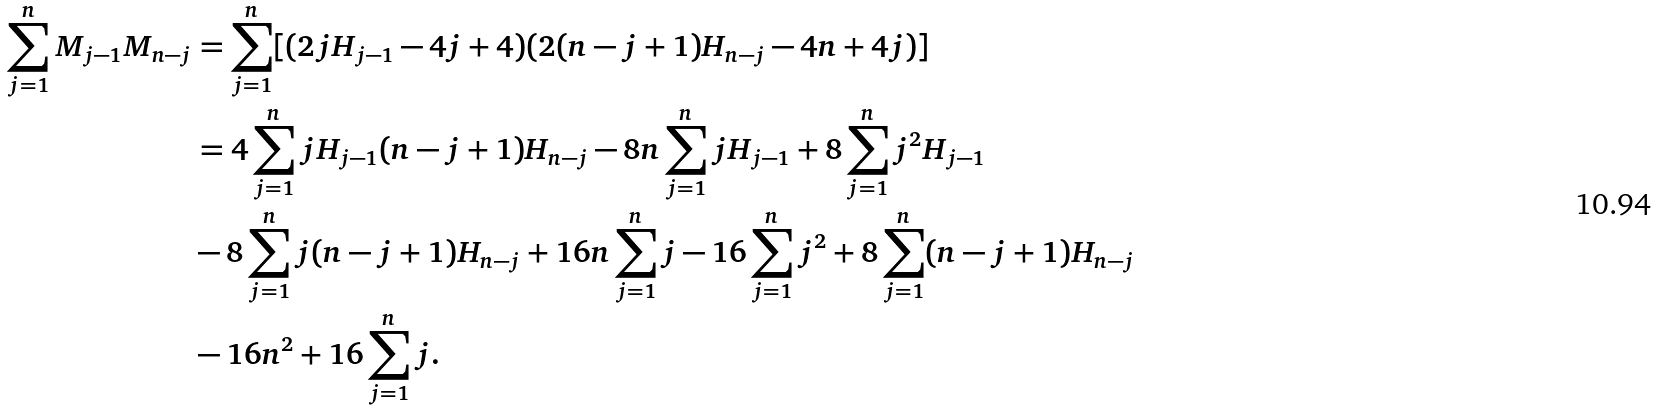<formula> <loc_0><loc_0><loc_500><loc_500>\sum _ { j = 1 } ^ { n } M _ { j - 1 } M _ { n - j } & = \sum _ { j = 1 } ^ { n } [ ( 2 j H _ { j - 1 } - 4 j + 4 ) ( 2 ( n - j + 1 ) H _ { n - j } - 4 n + 4 j ) ] \\ & = 4 \sum _ { j = 1 } ^ { n } j H _ { j - 1 } ( n - j + 1 ) H _ { n - j } - 8 n \sum _ { j = 1 } ^ { n } j H _ { j - 1 } + 8 \sum _ { j = 1 } ^ { n } j ^ { 2 } H _ { j - 1 } \\ & - 8 \sum _ { j = 1 } ^ { n } j ( n - j + 1 ) H _ { n - j } + 1 6 n \sum _ { j = 1 } ^ { n } j - 1 6 \sum _ { j = 1 } ^ { n } j ^ { 2 } + 8 \sum _ { j = 1 } ^ { n } ( n - j + 1 ) H _ { n - j } \\ & - 1 6 n ^ { 2 } + 1 6 \sum _ { j = 1 } ^ { n } j .</formula> 